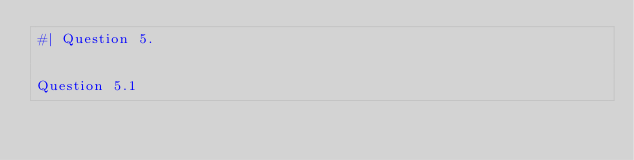Convert code to text. <code><loc_0><loc_0><loc_500><loc_500><_Lisp_>#| Question 5.


Question 5.1
</code> 